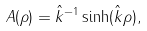Convert formula to latex. <formula><loc_0><loc_0><loc_500><loc_500>A ( \rho ) = \hat { k } ^ { - 1 } \sinh ( \hat { k } \rho ) ,</formula> 